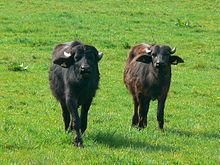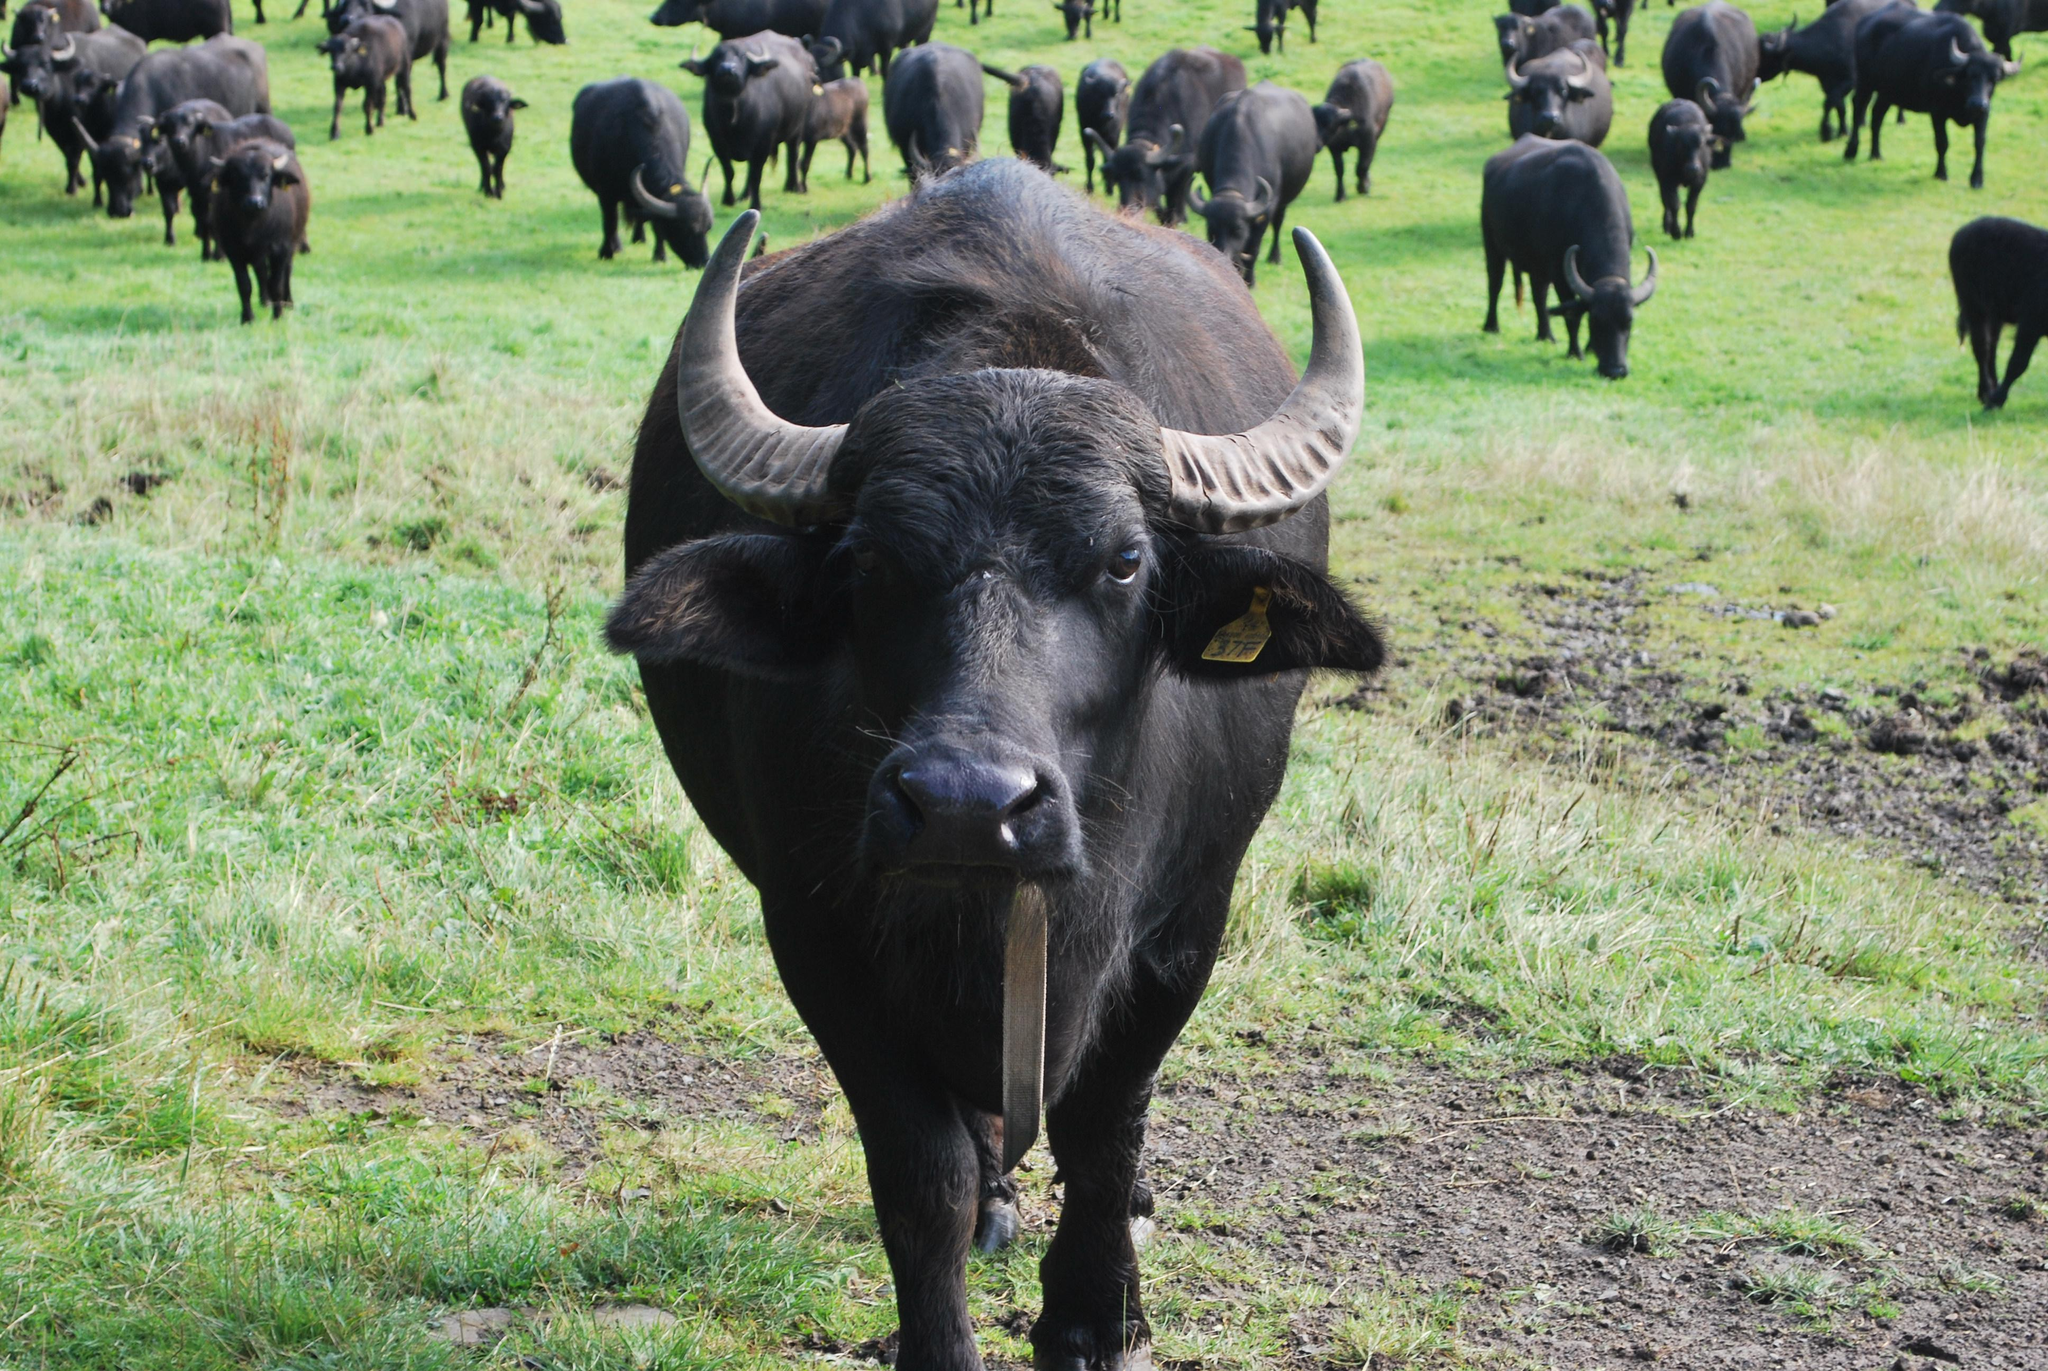The first image is the image on the left, the second image is the image on the right. Examine the images to the left and right. Is the description "In one image there are at least three standing water buffaloes where one is facing a different direction than the others." accurate? Answer yes or no. No. The first image is the image on the left, the second image is the image on the right. For the images shown, is this caption "The left image contains only very dark hooved animals surrounded by bright green grass, with the foreground animals facing directly forward." true? Answer yes or no. Yes. 